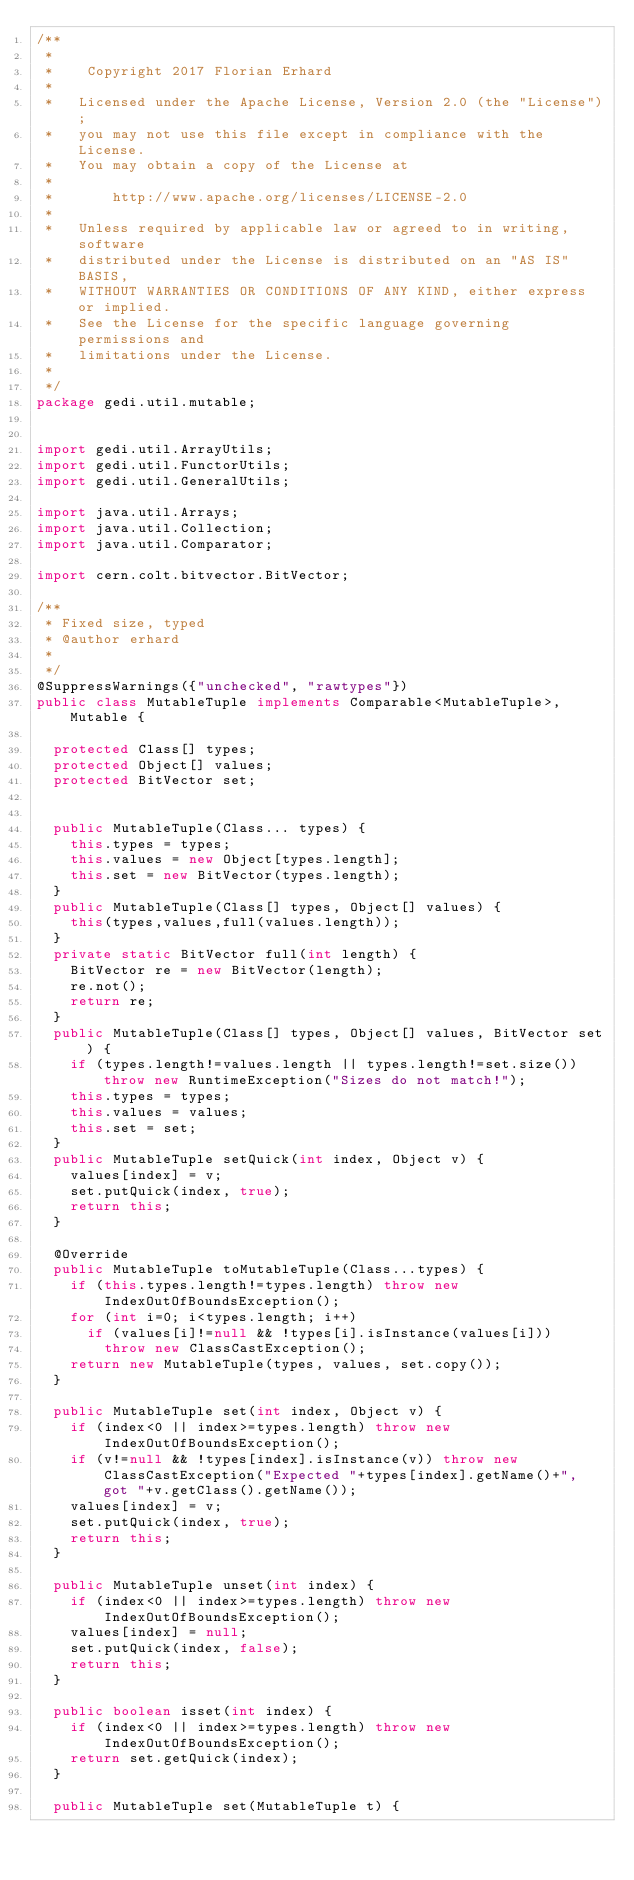<code> <loc_0><loc_0><loc_500><loc_500><_Java_>/**
 * 
 *    Copyright 2017 Florian Erhard
 *
 *   Licensed under the Apache License, Version 2.0 (the "License");
 *   you may not use this file except in compliance with the License.
 *   You may obtain a copy of the License at
 *
 *       http://www.apache.org/licenses/LICENSE-2.0
 *
 *   Unless required by applicable law or agreed to in writing, software
 *   distributed under the License is distributed on an "AS IS" BASIS,
 *   WITHOUT WARRANTIES OR CONDITIONS OF ANY KIND, either express or implied.
 *   See the License for the specific language governing permissions and
 *   limitations under the License.
 * 
 */
package gedi.util.mutable;


import gedi.util.ArrayUtils;
import gedi.util.FunctorUtils;
import gedi.util.GeneralUtils;

import java.util.Arrays;
import java.util.Collection;
import java.util.Comparator;

import cern.colt.bitvector.BitVector;

/**
 * Fixed size, typed
 * @author erhard
 *
 */
@SuppressWarnings({"unchecked", "rawtypes"})
public class MutableTuple implements Comparable<MutableTuple>, Mutable {
	
	protected Class[] types;
	protected Object[] values;
	protected BitVector set;
	
	
	public MutableTuple(Class... types) {
		this.types = types;
		this.values = new Object[types.length];
		this.set = new BitVector(types.length);
	}
	public MutableTuple(Class[] types, Object[] values) {
		this(types,values,full(values.length));
	}
	private static BitVector full(int length) {
		BitVector re = new BitVector(length);
		re.not();
		return re;
	}
	public MutableTuple(Class[] types, Object[] values, BitVector set) {
		if (types.length!=values.length || types.length!=set.size()) throw new RuntimeException("Sizes do not match!");
		this.types = types;
		this.values = values;
		this.set = set;
	}
	public MutableTuple setQuick(int index, Object v) {
		values[index] = v;
		set.putQuick(index, true);
		return this;
	}
	
	@Override
	public MutableTuple toMutableTuple(Class...types) {
		if (this.types.length!=types.length) throw new IndexOutOfBoundsException();
		for (int i=0; i<types.length; i++)
			if (values[i]!=null && !types[i].isInstance(values[i]))
				throw new ClassCastException();
		return new MutableTuple(types, values, set.copy());
	}
	
	public MutableTuple set(int index, Object v) {
		if (index<0 || index>=types.length) throw new IndexOutOfBoundsException();
		if (v!=null && !types[index].isInstance(v)) throw new ClassCastException("Expected "+types[index].getName()+", got "+v.getClass().getName());
		values[index] = v;
		set.putQuick(index, true);
		return this;
	}
	
	public MutableTuple unset(int index) {
		if (index<0 || index>=types.length) throw new IndexOutOfBoundsException();
		values[index] = null;
		set.putQuick(index, false);
		return this;
	}
	
	public boolean isset(int index) {
		if (index<0 || index>=types.length) throw new IndexOutOfBoundsException();
		return set.getQuick(index);
	}
	
	public MutableTuple set(MutableTuple t) {</code> 